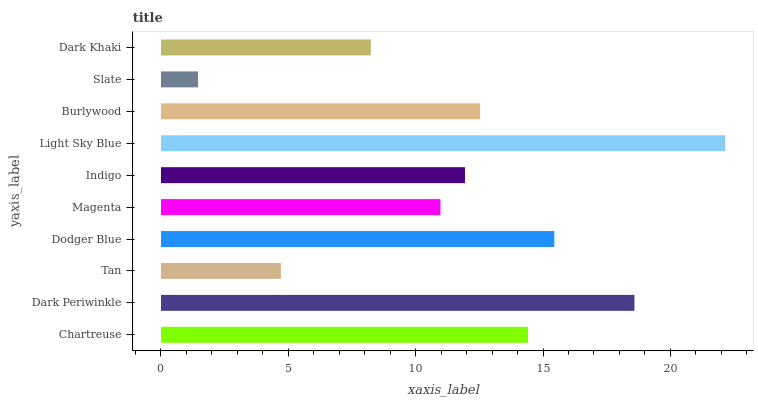Is Slate the minimum?
Answer yes or no. Yes. Is Light Sky Blue the maximum?
Answer yes or no. Yes. Is Dark Periwinkle the minimum?
Answer yes or no. No. Is Dark Periwinkle the maximum?
Answer yes or no. No. Is Dark Periwinkle greater than Chartreuse?
Answer yes or no. Yes. Is Chartreuse less than Dark Periwinkle?
Answer yes or no. Yes. Is Chartreuse greater than Dark Periwinkle?
Answer yes or no. No. Is Dark Periwinkle less than Chartreuse?
Answer yes or no. No. Is Burlywood the high median?
Answer yes or no. Yes. Is Indigo the low median?
Answer yes or no. Yes. Is Dodger Blue the high median?
Answer yes or no. No. Is Dodger Blue the low median?
Answer yes or no. No. 